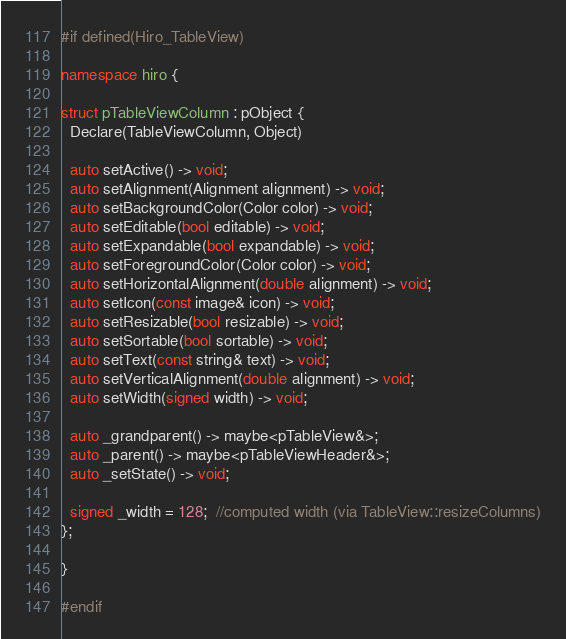Convert code to text. <code><loc_0><loc_0><loc_500><loc_500><_C++_>#if defined(Hiro_TableView)

namespace hiro {

struct pTableViewColumn : pObject {
  Declare(TableViewColumn, Object)

  auto setActive() -> void;
  auto setAlignment(Alignment alignment) -> void;
  auto setBackgroundColor(Color color) -> void;
  auto setEditable(bool editable) -> void;
  auto setExpandable(bool expandable) -> void;
  auto setForegroundColor(Color color) -> void;
  auto setHorizontalAlignment(double alignment) -> void;
  auto setIcon(const image& icon) -> void;
  auto setResizable(bool resizable) -> void;
  auto setSortable(bool sortable) -> void;
  auto setText(const string& text) -> void;
  auto setVerticalAlignment(double alignment) -> void;
  auto setWidth(signed width) -> void;

  auto _grandparent() -> maybe<pTableView&>;
  auto _parent() -> maybe<pTableViewHeader&>;
  auto _setState() -> void;

  signed _width = 128;  //computed width (via TableView::resizeColumns)
};

}

#endif
</code> 